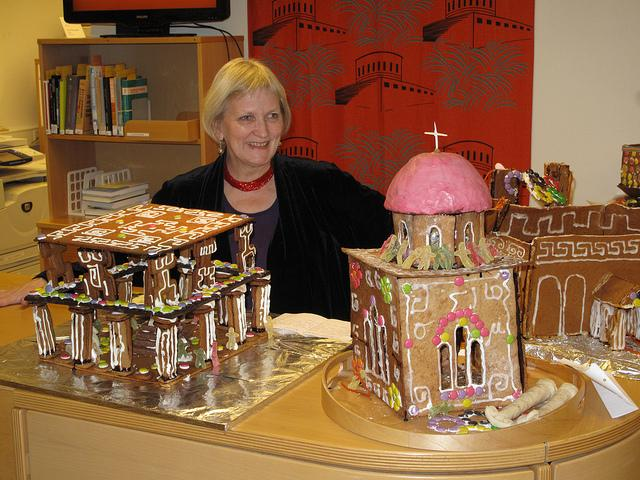What are these buildings mostly made of? Please explain your reasoning. gingerbread. The buildings are made of gingerbread. 